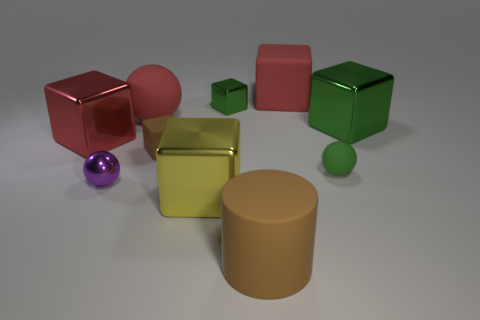Subtract all small green spheres. How many spheres are left? 2 Subtract all red cubes. How many cubes are left? 4 Subtract all balls. How many objects are left? 7 Subtract 1 cylinders. How many cylinders are left? 0 Add 6 green rubber objects. How many green rubber objects are left? 7 Add 1 blocks. How many blocks exist? 7 Subtract 0 yellow spheres. How many objects are left? 10 Subtract all red cubes. Subtract all gray cylinders. How many cubes are left? 4 Subtract all brown cylinders. How many blue balls are left? 0 Subtract all small cubes. Subtract all brown matte things. How many objects are left? 6 